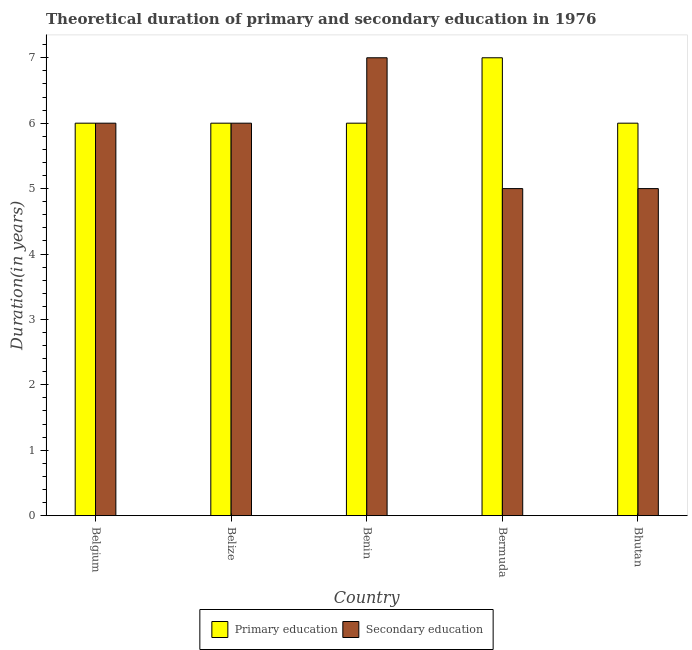How many groups of bars are there?
Ensure brevity in your answer.  5. How many bars are there on the 5th tick from the left?
Make the answer very short. 2. What is the label of the 2nd group of bars from the left?
Ensure brevity in your answer.  Belize. In how many cases, is the number of bars for a given country not equal to the number of legend labels?
Provide a short and direct response. 0. What is the duration of secondary education in Belize?
Provide a succinct answer. 6. Across all countries, what is the maximum duration of primary education?
Ensure brevity in your answer.  7. In which country was the duration of primary education maximum?
Provide a short and direct response. Bermuda. In which country was the duration of secondary education minimum?
Your answer should be compact. Bermuda. What is the total duration of primary education in the graph?
Offer a very short reply. 31. What is the difference between the duration of primary education in Benin and that in Bermuda?
Provide a short and direct response. -1. What is the difference between the duration of secondary education in Benin and the duration of primary education in Bhutan?
Provide a short and direct response. 1. What is the difference between the duration of secondary education and duration of primary education in Bhutan?
Provide a short and direct response. -1. In how many countries, is the duration of secondary education greater than 5 years?
Keep it short and to the point. 3. Is the difference between the duration of secondary education in Belize and Benin greater than the difference between the duration of primary education in Belize and Benin?
Your answer should be very brief. No. What is the difference between the highest and the lowest duration of primary education?
Your response must be concise. 1. What does the 2nd bar from the left in Bermuda represents?
Provide a succinct answer. Secondary education. What does the 2nd bar from the right in Benin represents?
Ensure brevity in your answer.  Primary education. How many bars are there?
Your answer should be very brief. 10. Are all the bars in the graph horizontal?
Make the answer very short. No. How many countries are there in the graph?
Give a very brief answer. 5. What is the difference between two consecutive major ticks on the Y-axis?
Provide a succinct answer. 1. Does the graph contain any zero values?
Ensure brevity in your answer.  No. What is the title of the graph?
Your answer should be compact. Theoretical duration of primary and secondary education in 1976. What is the label or title of the X-axis?
Your answer should be compact. Country. What is the label or title of the Y-axis?
Provide a short and direct response. Duration(in years). What is the Duration(in years) in Primary education in Belgium?
Offer a very short reply. 6. What is the Duration(in years) of Secondary education in Belize?
Provide a short and direct response. 6. What is the Duration(in years) of Secondary education in Benin?
Your answer should be very brief. 7. What is the Duration(in years) in Primary education in Bermuda?
Keep it short and to the point. 7. Across all countries, what is the maximum Duration(in years) of Secondary education?
Offer a very short reply. 7. Across all countries, what is the minimum Duration(in years) of Primary education?
Your answer should be compact. 6. What is the total Duration(in years) in Primary education in the graph?
Your response must be concise. 31. What is the total Duration(in years) of Secondary education in the graph?
Provide a short and direct response. 29. What is the difference between the Duration(in years) in Secondary education in Belgium and that in Belize?
Ensure brevity in your answer.  0. What is the difference between the Duration(in years) of Primary education in Belgium and that in Benin?
Offer a terse response. 0. What is the difference between the Duration(in years) of Primary education in Belgium and that in Bermuda?
Make the answer very short. -1. What is the difference between the Duration(in years) of Primary education in Belgium and that in Bhutan?
Your answer should be compact. 0. What is the difference between the Duration(in years) of Secondary education in Belgium and that in Bhutan?
Your answer should be compact. 1. What is the difference between the Duration(in years) in Secondary education in Belize and that in Benin?
Make the answer very short. -1. What is the difference between the Duration(in years) of Secondary education in Belize and that in Bermuda?
Your answer should be compact. 1. What is the difference between the Duration(in years) in Primary education in Belize and that in Bhutan?
Provide a succinct answer. 0. What is the difference between the Duration(in years) of Secondary education in Belize and that in Bhutan?
Your answer should be compact. 1. What is the difference between the Duration(in years) of Secondary education in Benin and that in Bermuda?
Provide a short and direct response. 2. What is the difference between the Duration(in years) in Primary education in Benin and that in Bhutan?
Your answer should be compact. 0. What is the difference between the Duration(in years) of Secondary education in Benin and that in Bhutan?
Your response must be concise. 2. What is the difference between the Duration(in years) in Primary education in Bermuda and that in Bhutan?
Your answer should be compact. 1. What is the difference between the Duration(in years) of Secondary education in Bermuda and that in Bhutan?
Offer a very short reply. 0. What is the difference between the Duration(in years) of Primary education in Belgium and the Duration(in years) of Secondary education in Belize?
Ensure brevity in your answer.  0. What is the difference between the Duration(in years) in Primary education in Belgium and the Duration(in years) in Secondary education in Bermuda?
Provide a succinct answer. 1. What is the difference between the Duration(in years) of Primary education in Belize and the Duration(in years) of Secondary education in Bermuda?
Provide a short and direct response. 1. What is the difference between the Duration(in years) in Primary education in Belize and the Duration(in years) in Secondary education in Bhutan?
Ensure brevity in your answer.  1. What is the difference between the Duration(in years) in Primary education in Benin and the Duration(in years) in Secondary education in Bhutan?
Give a very brief answer. 1. What is the average Duration(in years) of Secondary education per country?
Your answer should be compact. 5.8. What is the difference between the Duration(in years) in Primary education and Duration(in years) in Secondary education in Belize?
Make the answer very short. 0. What is the difference between the Duration(in years) in Primary education and Duration(in years) in Secondary education in Bermuda?
Provide a short and direct response. 2. What is the ratio of the Duration(in years) in Secondary education in Belgium to that in Belize?
Your response must be concise. 1. What is the ratio of the Duration(in years) in Primary education in Belgium to that in Benin?
Your response must be concise. 1. What is the ratio of the Duration(in years) of Secondary education in Belgium to that in Bermuda?
Make the answer very short. 1.2. What is the ratio of the Duration(in years) of Primary education in Belgium to that in Bhutan?
Ensure brevity in your answer.  1. What is the ratio of the Duration(in years) in Secondary education in Belgium to that in Bhutan?
Keep it short and to the point. 1.2. What is the ratio of the Duration(in years) in Primary education in Belize to that in Benin?
Give a very brief answer. 1. What is the ratio of the Duration(in years) of Secondary education in Belize to that in Benin?
Make the answer very short. 0.86. What is the ratio of the Duration(in years) in Secondary education in Belize to that in Bhutan?
Give a very brief answer. 1.2. What is the ratio of the Duration(in years) of Primary education in Benin to that in Bermuda?
Make the answer very short. 0.86. What is the ratio of the Duration(in years) in Primary education in Benin to that in Bhutan?
Keep it short and to the point. 1. What is the ratio of the Duration(in years) of Secondary education in Bermuda to that in Bhutan?
Your answer should be very brief. 1. What is the difference between the highest and the second highest Duration(in years) in Primary education?
Provide a short and direct response. 1. What is the difference between the highest and the second highest Duration(in years) in Secondary education?
Give a very brief answer. 1. What is the difference between the highest and the lowest Duration(in years) of Primary education?
Your response must be concise. 1. 